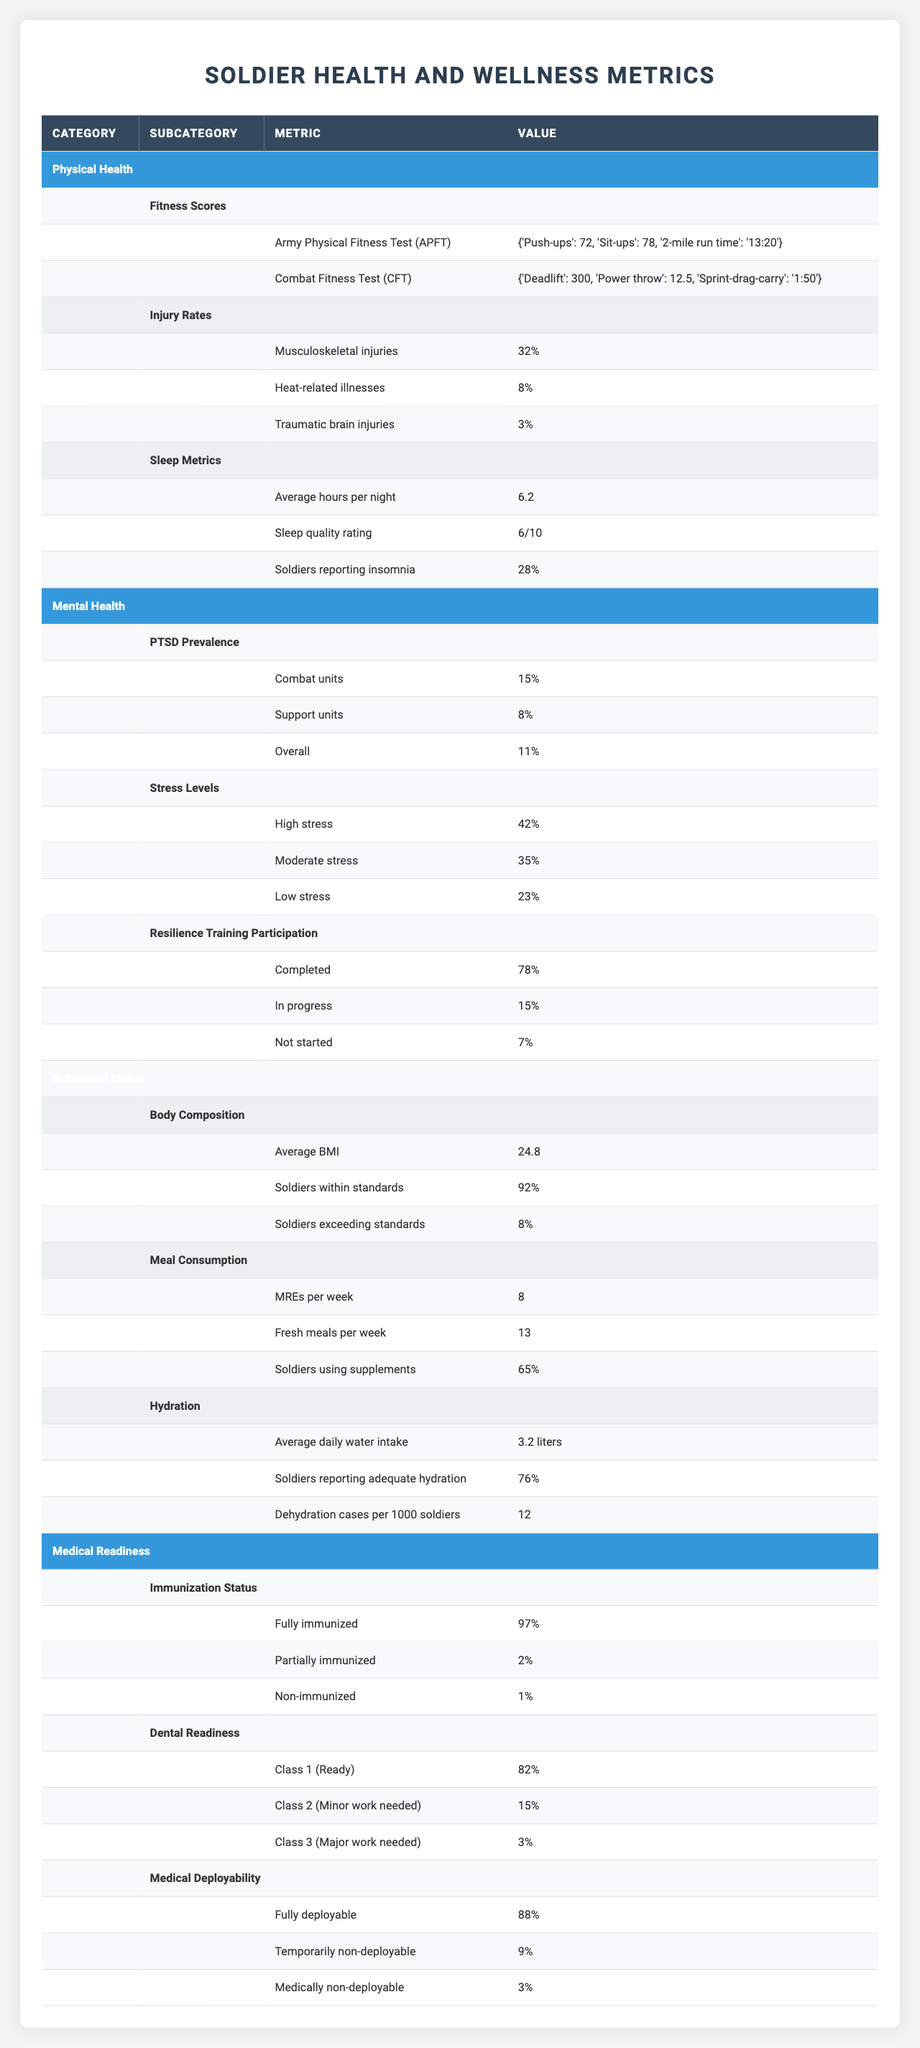What is the average sleep quality rating among soldiers? The sleep quality rating given in the table is "6/10". Thus, this is the average sleep quality rating among soldiers.
Answer: 6/10 What percentage of soldiers report suffering from insomnia? The table states that 28% of soldiers report insomnia. Therefore, the answer is 28%.
Answer: 28% Which has a higher prevalence of PTSD: combat units or support units? The table indicates that PTSD prevalence in combat units is 15% and in support units is 8%. Since 15% is greater than 8%, combat units have a higher prevalence.
Answer: Combat units What is the percentage of soldiers with musculoskeletal injuries? According to the table, the percentage of soldiers with musculoskeletal injuries is 32%.
Answer: 32% How many more soldiers report high stress compared to low stress? High stress is reported by 42% of soldiers, while low stress is reported by 23%. Thus, the difference is 42% - 23% = 19%.
Answer: 19% What is the total percentage of soldiers who are either partially or non-immunized? From the table, 2% are partially immunized and 1% are non-immunized. Adding these gives 2% + 1% = 3%.
Answer: 3% If 92% of soldiers are within body composition standards, what percentage are exceeding those standards? The table states that 8% of soldiers are exceeding body composition standards. Therefore, the answer is simply 8%.
Answer: 8% What is the average daily water intake compared to soldiers reporting adequate hydration? The average daily water intake is 3.2 liters, and 76% report adequate hydration. These two metrics are different measures and cannot be directly compared, but we can state each separately.
Answer: 3.2 liters; 76% What is the ratio of soldiers fully deployable to those medically non-deployable? The fully deployable percentage is 88%, while medically non-deployable is 3%. The ratio is 88:3, which can also be expressed as approximately 29.33:1.
Answer: 29.33:1 What percentage of soldiers completed resilience training? According to the table, 78% of soldiers have completed resilience training.
Answer: 78% What is the combined percentage of soldiers experiencing high or moderate stress? High stress is 42% and moderate stress is 35%. Adding these gives 42% + 35% = 77%.
Answer: 77% 